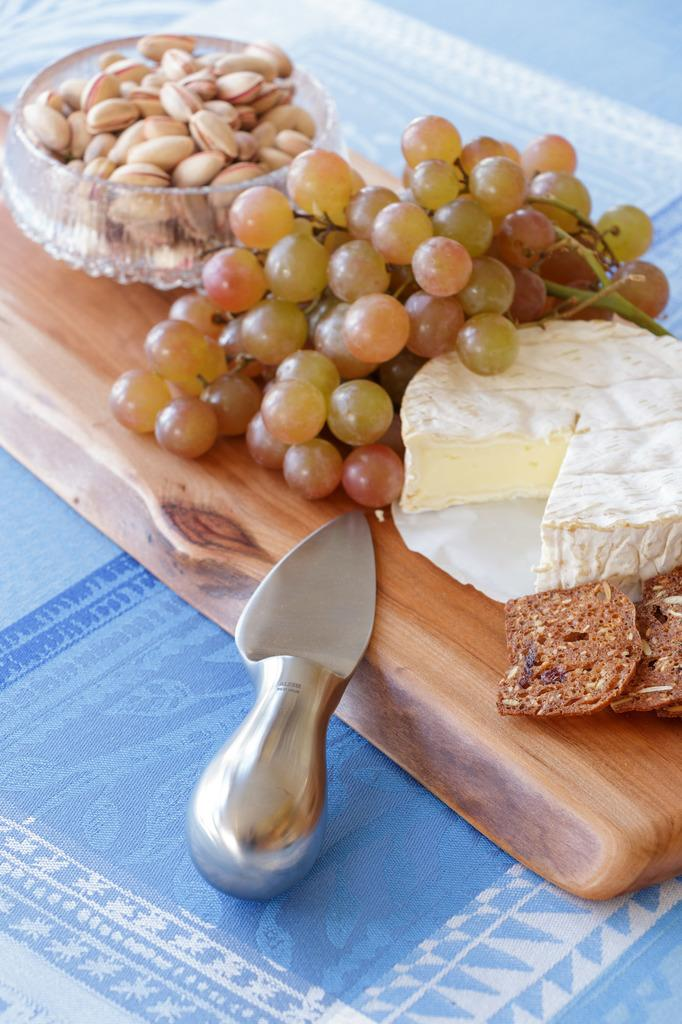What type of fruit can be seen in the image? There are grapes in the image. What other food item is present in the image? There are almonds in the image. Where are the grapes and almonds located? The grapes and almonds are in a bowl. What dairy product is visible in the image? There is a slice of butter in the image. What utensil is present in the image? There is a knife in the image. On what surface are the objects placed? The objects are on a wooden plank. What type of appliance is used to cut the nerve in the image? There is no appliance or nerve present in the image; it features grapes, almonds, butter, a knife, and a wooden plank. 